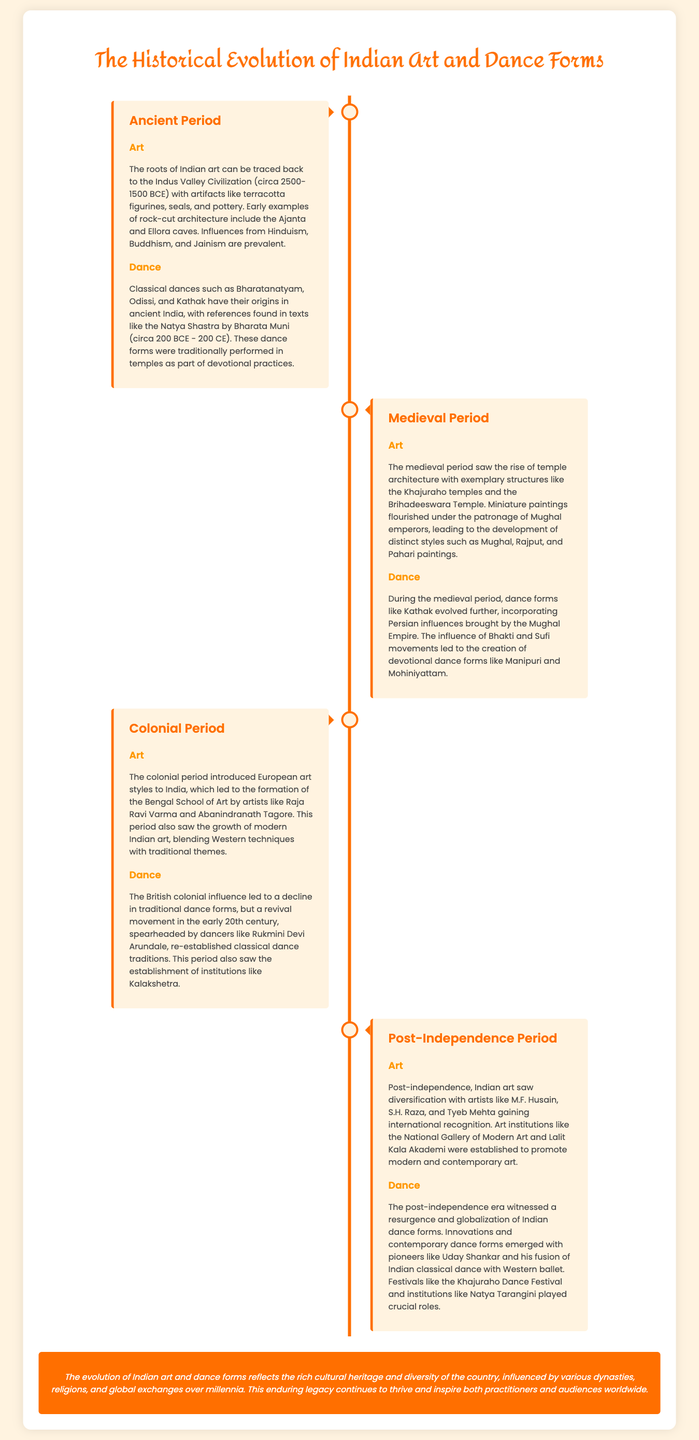What is the earliest civilization mentioned in the context of Indian art? The document states that the roots of Indian art can be traced back to the Indus Valley Civilization, which existed from circa 2500-1500 BCE.
Answer: Indus Valley Civilization Which classical dance is associated with the Natya Shastra? The document mentions that Bharatanatyam, Odissi, and Kathak have their origins in ancient India, with references found in the Natya Shastra.
Answer: Bharatanatyam What significant architectural structures are highlighted in the medieval period? The text notes the rise of temple architecture with exemplary structures like the Khajuraho temples and the Brihadeeswara Temple during the medieval period.
Answer: Khajuraho temples, Brihadeeswara Temple Who was a key figure in the revival of classical dance traditions in the colonial period? The document specifically identifies Rukmini Devi Arundale as a key figure in the revival of traditional dance forms during the British colonial influence.
Answer: Rukmini Devi Arundale In which period did Indian artists gain international recognition? The document indicates that post-independence, artists like M.F. Husain, S.H. Raza, and Tyeb Mehta gained international recognition.
Answer: Post-Independence Period What is the theme of the conclusion section? The conclusion summarizes the influence of various dynasties, religions, and global exchanges on the evolution of Indian art and dance forms over time.
Answer: Cultural heritage and diversity Which dance forms were influenced by the Mughal Empire? The medieval period mentions that dance forms like Kathak evolved further, incorporating Persian influences brought by the Mughal Empire.
Answer: Kathak What was a notable establishment for modern art during the post-independence period? The document mentions the establishment of institutions like the National Gallery of Modern Art and Lalit Kala Akademi post-independence.
Answer: National Gallery of Modern Art Which dance festival is highlighted for its role in the resurgence of Indian dance forms? The text refers to the Khajuraho Dance Festival as playing a crucial role in the resurgence of Indian dance forms.
Answer: Khajuraho Dance Festival 